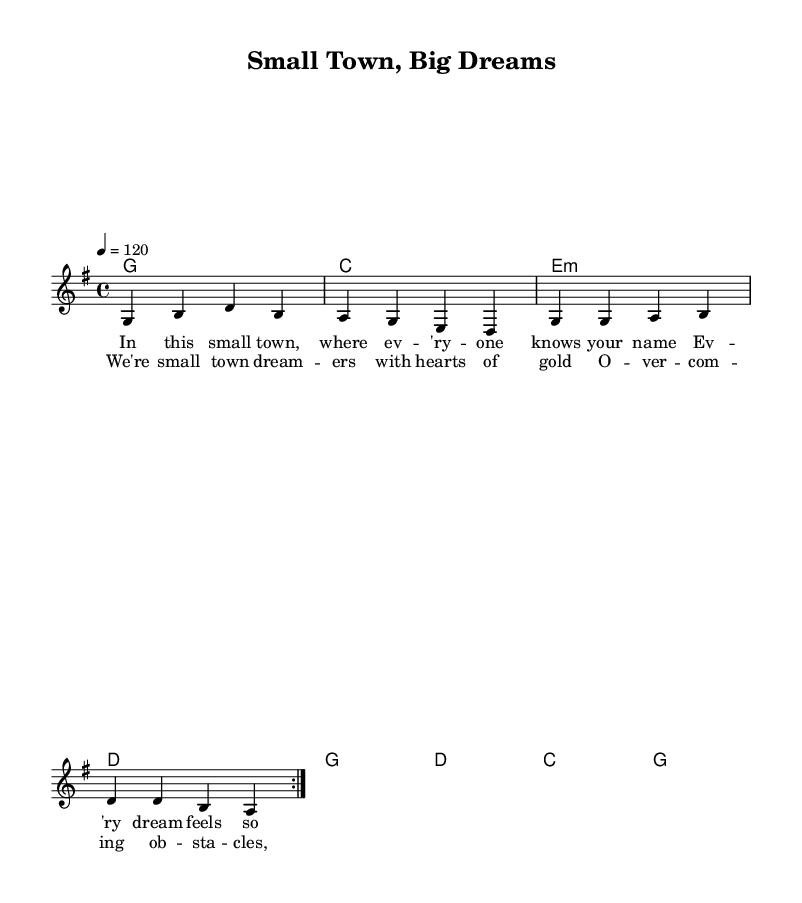What is the key signature of this music? The key signature is G major, which has one sharp (F#). This is determined by looking at the key indicated in the global section of the code.
Answer: G major What is the time signature of this music? The time signature is 4/4, which means there are four beats in each measure and the quarter note gets one beat. This is similarly noted in the global section of the code.
Answer: 4/4 What is the tempo of this music? The tempo is set at 120 beats per minute, as indicated by the tempo marking in the global section.
Answer: 120 How many verses are repeated in the melody? The melody includes a repeated section for a total of two verses, as specified by the repeat volta marking.
Answer: Two What genre does this sheet music represent? The sheet music represents the "Country Rock" genre, which is characterized by its blending of country music elements with rock music influences. This is inferred from the context of the song titled "Small Town, Big Dreams."
Answer: Country Rock Which chord is played at the beginning of the harmony section? The first chord in the harmony section is G, which can be found in the chord mode part of the code, showing the first chord listed.
Answer: G What sentiment is expressed in the chorus lyrics? The chorus lyrics express a sense of determination and community, as they emphasize overcoming obstacles and unearthing untold stories, reflecting the close-knit community aspect typical in Country Rock anthems.
Answer: Overcoming obstacles 